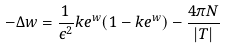Convert formula to latex. <formula><loc_0><loc_0><loc_500><loc_500>- \Delta w = \frac { 1 } { \epsilon ^ { 2 } } k e ^ { w } ( 1 - k e ^ { w } ) - \frac { 4 \pi N } { | T | }</formula> 